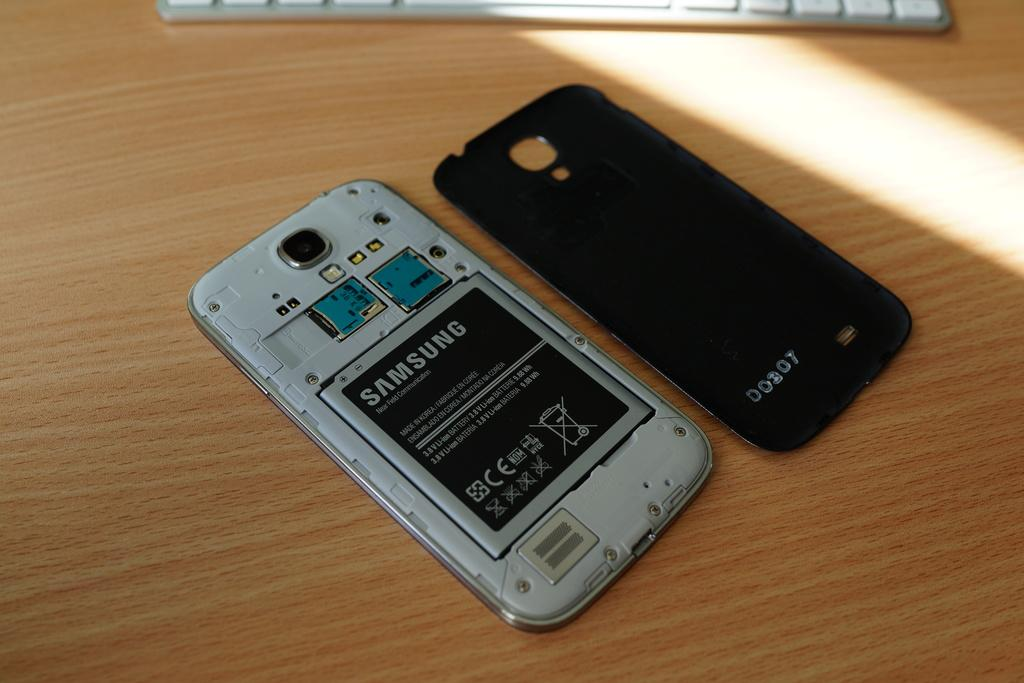<image>
Provide a brief description of the given image. A Samsung branded cellphone with its back cover popped off. 